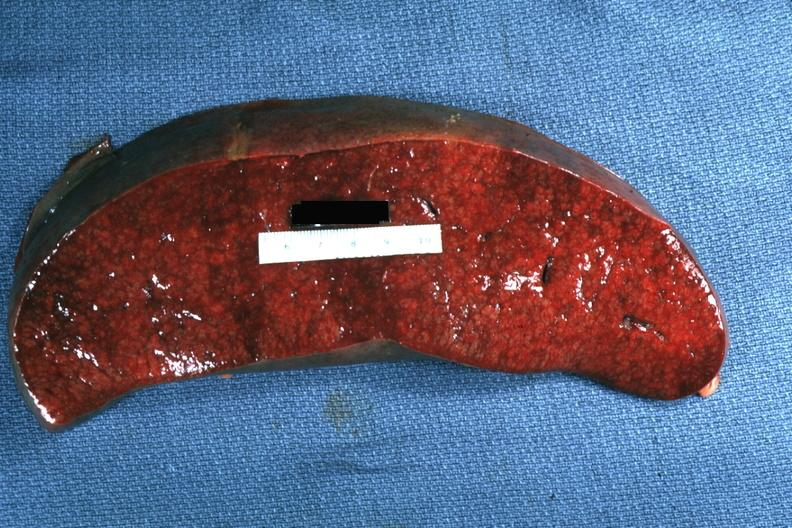what does this image show?
Answer the question using a single word or phrase. Cut surface with apparent infiltrative process case of chronic lymphocytic leukemia progressing to acute lymphocytic leukemia 